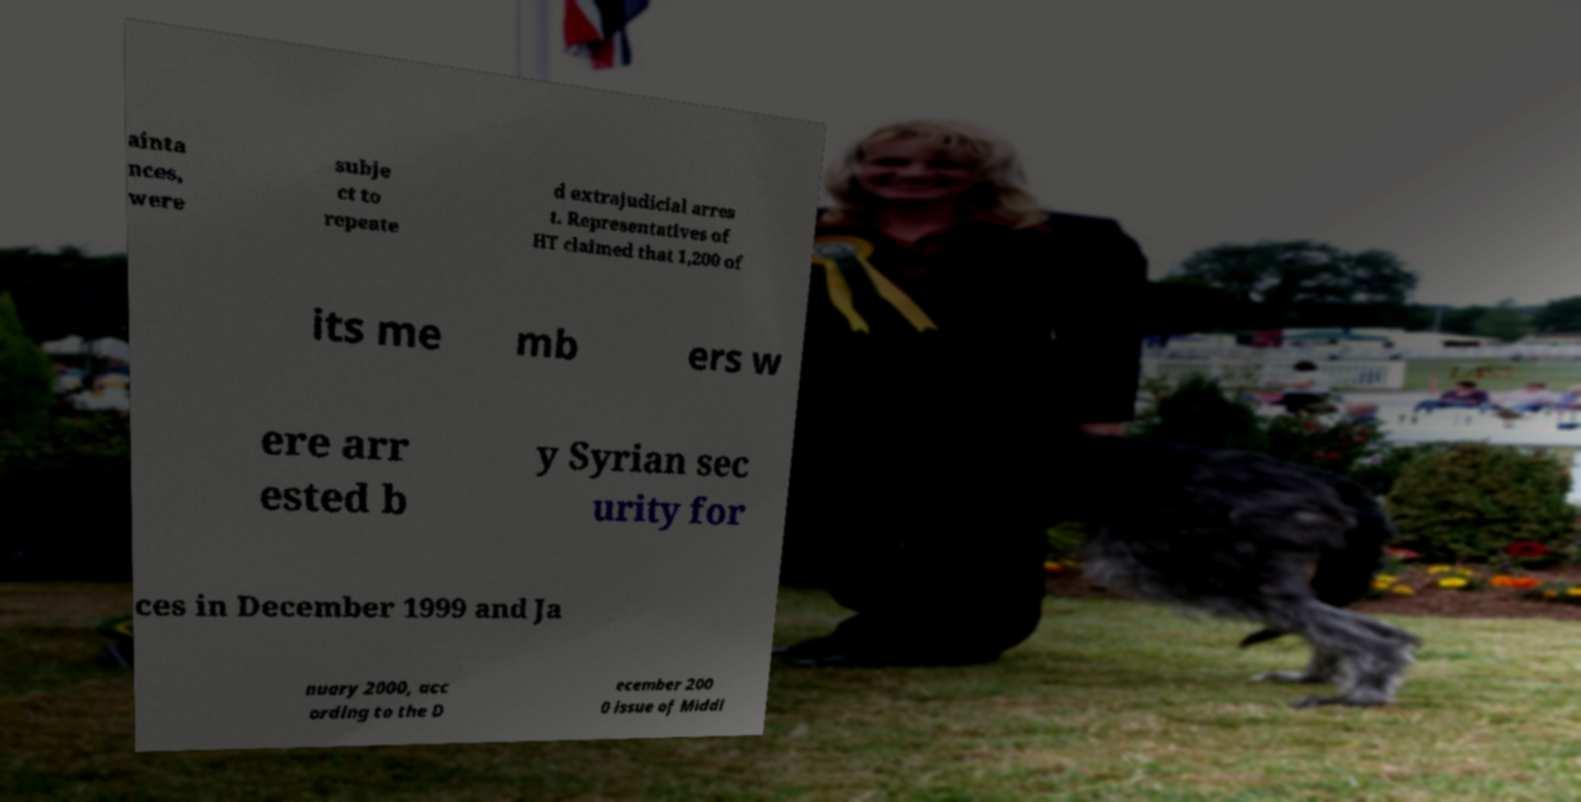There's text embedded in this image that I need extracted. Can you transcribe it verbatim? ainta nces, were subje ct to repeate d extrajudicial arres t. Representatives of HT claimed that 1,200 of its me mb ers w ere arr ested b y Syrian sec urity for ces in December 1999 and Ja nuary 2000, acc ording to the D ecember 200 0 issue of Middl 